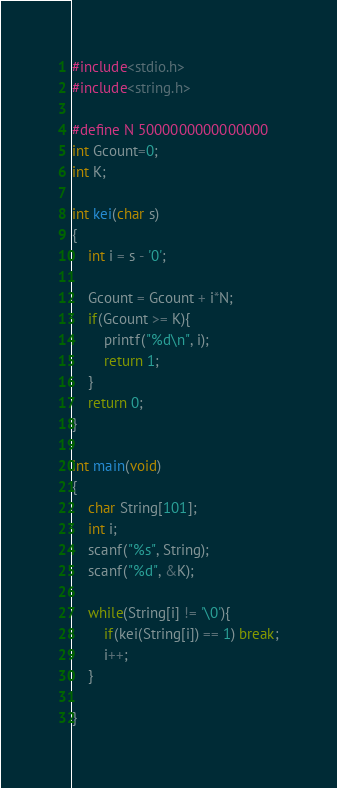<code> <loc_0><loc_0><loc_500><loc_500><_C_>#include<stdio.h>
#include<string.h>

#define N 5000000000000000
int Gcount=0;
int K;

int kei(char s)
{
    int i = s - '0';

    Gcount = Gcount + i*N;
    if(Gcount >= K){
        printf("%d\n", i);
        return 1;
    }
    return 0;
}

int main(void)
{
    char String[101];
    int i;
    scanf("%s", String);
    scanf("%d", &K);

    while(String[i] != '\0'){
        if(kei(String[i]) == 1) break;
        i++;
    }
    
}</code> 